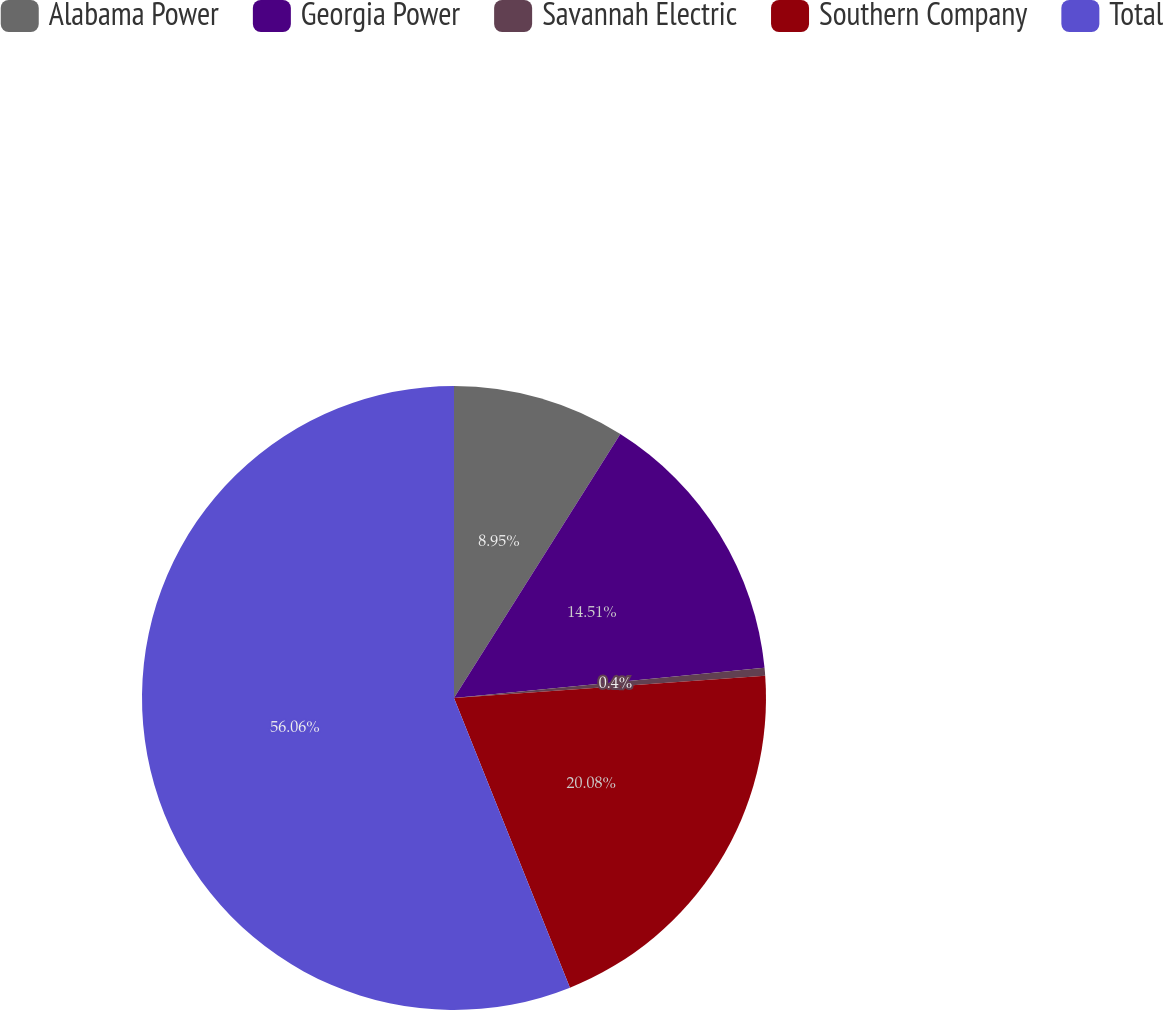<chart> <loc_0><loc_0><loc_500><loc_500><pie_chart><fcel>Alabama Power<fcel>Georgia Power<fcel>Savannah Electric<fcel>Southern Company<fcel>Total<nl><fcel>8.95%<fcel>14.51%<fcel>0.4%<fcel>20.08%<fcel>56.06%<nl></chart> 